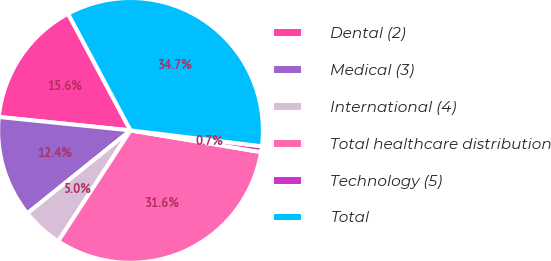Convert chart to OTSL. <chart><loc_0><loc_0><loc_500><loc_500><pie_chart><fcel>Dental (2)<fcel>Medical (3)<fcel>International (4)<fcel>Total healthcare distribution<fcel>Technology (5)<fcel>Total<nl><fcel>15.56%<fcel>12.4%<fcel>5.02%<fcel>31.58%<fcel>0.71%<fcel>34.73%<nl></chart> 